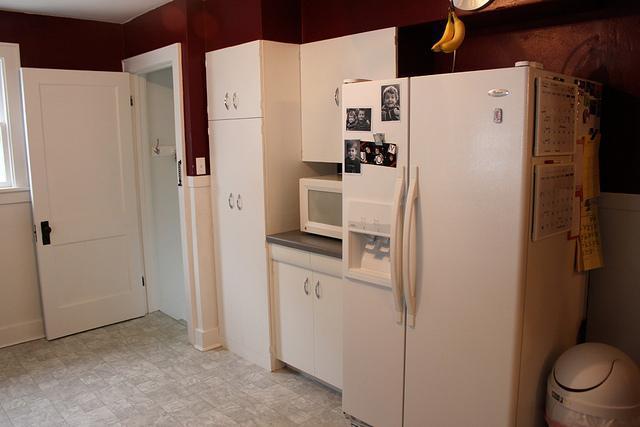How many appliances are there?
Give a very brief answer. 2. How many bananas do they have?
Give a very brief answer. 2. How many refrigerators are visible?
Give a very brief answer. 1. 